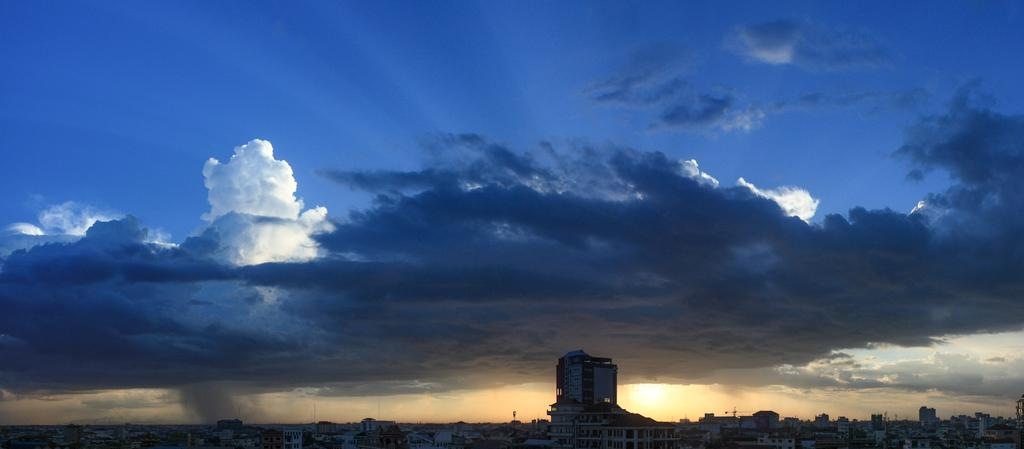What type of structures can be seen in the image? There are buildings in the image. What is visible at the top of the image? The sky is visible at the top of the image. How would you describe the sky in the image? The sky appears to be cloudy. Can you see a fireman having breakfast under a veil in the image? No, there is no fireman, breakfast, or veil present in the image. 